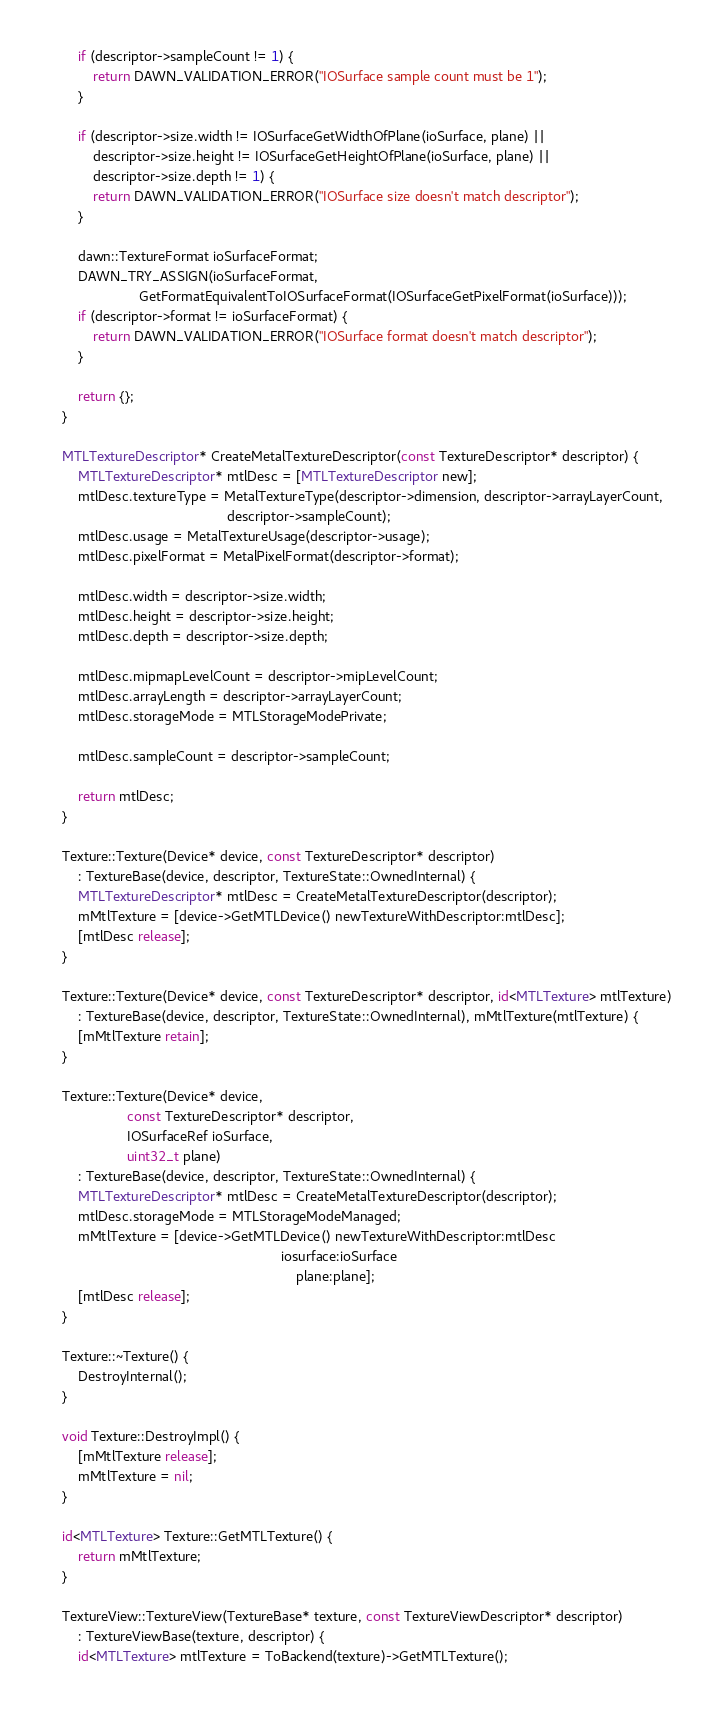Convert code to text. <code><loc_0><loc_0><loc_500><loc_500><_ObjectiveC_>        if (descriptor->sampleCount != 1) {
            return DAWN_VALIDATION_ERROR("IOSurface sample count must be 1");
        }

        if (descriptor->size.width != IOSurfaceGetWidthOfPlane(ioSurface, plane) ||
            descriptor->size.height != IOSurfaceGetHeightOfPlane(ioSurface, plane) ||
            descriptor->size.depth != 1) {
            return DAWN_VALIDATION_ERROR("IOSurface size doesn't match descriptor");
        }

        dawn::TextureFormat ioSurfaceFormat;
        DAWN_TRY_ASSIGN(ioSurfaceFormat,
                        GetFormatEquivalentToIOSurfaceFormat(IOSurfaceGetPixelFormat(ioSurface)));
        if (descriptor->format != ioSurfaceFormat) {
            return DAWN_VALIDATION_ERROR("IOSurface format doesn't match descriptor");
        }

        return {};
    }

    MTLTextureDescriptor* CreateMetalTextureDescriptor(const TextureDescriptor* descriptor) {
        MTLTextureDescriptor* mtlDesc = [MTLTextureDescriptor new];
        mtlDesc.textureType = MetalTextureType(descriptor->dimension, descriptor->arrayLayerCount,
                                               descriptor->sampleCount);
        mtlDesc.usage = MetalTextureUsage(descriptor->usage);
        mtlDesc.pixelFormat = MetalPixelFormat(descriptor->format);

        mtlDesc.width = descriptor->size.width;
        mtlDesc.height = descriptor->size.height;
        mtlDesc.depth = descriptor->size.depth;

        mtlDesc.mipmapLevelCount = descriptor->mipLevelCount;
        mtlDesc.arrayLength = descriptor->arrayLayerCount;
        mtlDesc.storageMode = MTLStorageModePrivate;

        mtlDesc.sampleCount = descriptor->sampleCount;

        return mtlDesc;
    }

    Texture::Texture(Device* device, const TextureDescriptor* descriptor)
        : TextureBase(device, descriptor, TextureState::OwnedInternal) {
        MTLTextureDescriptor* mtlDesc = CreateMetalTextureDescriptor(descriptor);
        mMtlTexture = [device->GetMTLDevice() newTextureWithDescriptor:mtlDesc];
        [mtlDesc release];
    }

    Texture::Texture(Device* device, const TextureDescriptor* descriptor, id<MTLTexture> mtlTexture)
        : TextureBase(device, descriptor, TextureState::OwnedInternal), mMtlTexture(mtlTexture) {
        [mMtlTexture retain];
    }

    Texture::Texture(Device* device,
                     const TextureDescriptor* descriptor,
                     IOSurfaceRef ioSurface,
                     uint32_t plane)
        : TextureBase(device, descriptor, TextureState::OwnedInternal) {
        MTLTextureDescriptor* mtlDesc = CreateMetalTextureDescriptor(descriptor);
        mtlDesc.storageMode = MTLStorageModeManaged;
        mMtlTexture = [device->GetMTLDevice() newTextureWithDescriptor:mtlDesc
                                                             iosurface:ioSurface
                                                                 plane:plane];
        [mtlDesc release];
    }

    Texture::~Texture() {
        DestroyInternal();
    }

    void Texture::DestroyImpl() {
        [mMtlTexture release];
        mMtlTexture = nil;
    }

    id<MTLTexture> Texture::GetMTLTexture() {
        return mMtlTexture;
    }

    TextureView::TextureView(TextureBase* texture, const TextureViewDescriptor* descriptor)
        : TextureViewBase(texture, descriptor) {
        id<MTLTexture> mtlTexture = ToBackend(texture)->GetMTLTexture();
</code> 